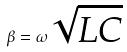<formula> <loc_0><loc_0><loc_500><loc_500>\beta = \omega \sqrt { L C }</formula> 